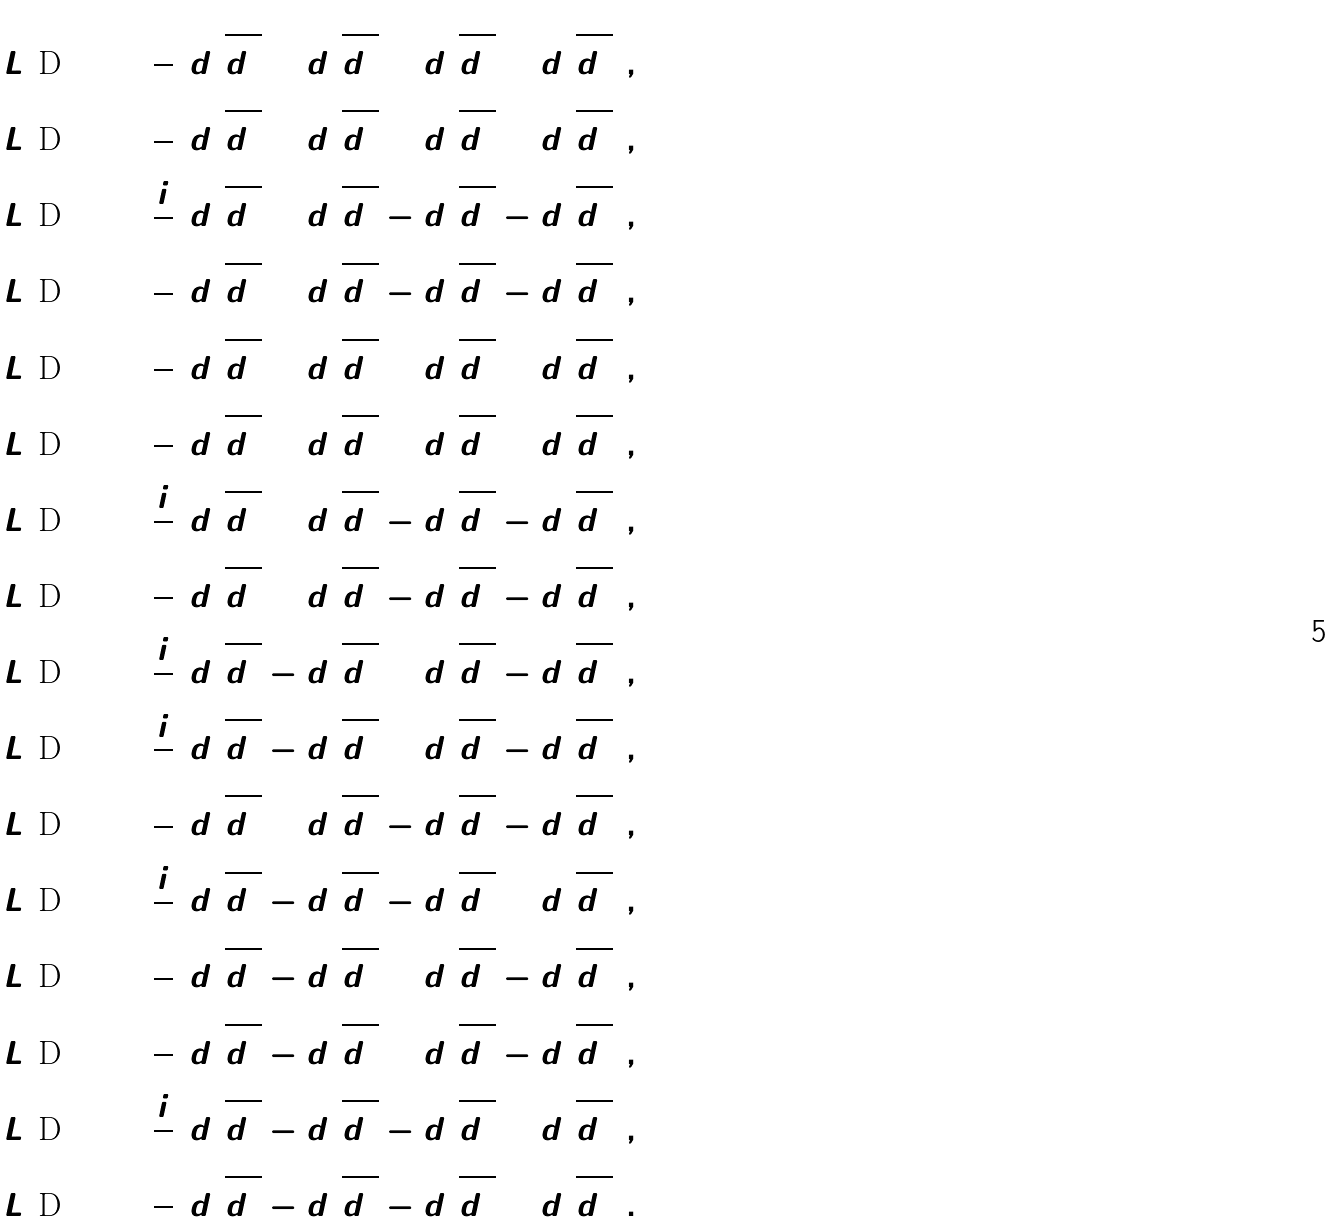Convert formula to latex. <formula><loc_0><loc_0><loc_500><loc_500>L ( \text {D} _ { 2 } ) ^ { 0 } _ { 0 } & = \frac { 1 } { 2 } ( d ^ { 1 } _ { 1 } \overline { d ^ { \dot { 1 } } _ { \dot { 1 } } } + d ^ { 1 } _ { 2 } \overline { d ^ { \dot { 1 } } _ { \dot { 2 } } } + d ^ { 2 } _ { 1 } \overline { d ^ { \dot { 2 } } _ { \dot { 1 } } } + d ^ { 2 } _ { 2 } \overline { d ^ { \dot { 2 } } _ { \dot { 2 } } } ) , \\ L ( \text {D} _ { 2 } ) ^ { 0 } _ { 1 } & = \frac { 1 } { 2 } ( d ^ { 1 } _ { 1 } \overline { d ^ { \dot { 1 } } _ { \dot { 2 } } } + d ^ { 2 } _ { 1 } \overline { d ^ { \dot { 2 } } _ { \dot { 2 } } } + d ^ { 1 } _ { 2 } \overline { d ^ { \dot { 1 } } _ { \dot { 1 } } } + d ^ { 2 } _ { 2 } \overline { d ^ { \dot { 2 } } _ { \dot { 1 } } } ) , \\ L ( \text {D} _ { 2 } ) ^ { 0 } _ { 2 } & = \frac { i } { 2 } ( d ^ { 1 } _ { 2 } \overline { d ^ { \dot { 1 } } _ { \dot { 1 } } } + d ^ { 2 } _ { 2 } \overline { d ^ { \dot { 2 } } _ { \dot { 1 } } } - d ^ { 1 } _ { 1 } \overline { d ^ { \dot { 1 } } _ { \dot { 2 } } } - d ^ { 2 } _ { 1 } \overline { d ^ { \dot { 2 } } _ { \dot { 2 } } } ) , \\ L ( \text {D} _ { 2 } ) ^ { 0 } _ { 3 } & = \frac { 1 } { 2 } ( d ^ { 1 } _ { 1 } \overline { d ^ { \dot { 1 } } _ { \dot { 1 } } } + d ^ { 2 } _ { 1 } \overline { d ^ { \dot { 2 } } _ { \dot { 1 } } } - d ^ { 1 } _ { 2 } \overline { d ^ { \dot { 1 } } _ { \dot { 2 } } } - d ^ { 2 } _ { 2 } \overline { d ^ { \dot { 2 } } _ { \dot { 2 } } } ) , \\ L ( \text {D} _ { 2 } ) ^ { 1 } _ { 0 } & = \frac { 1 } { 2 } ( d ^ { 1 } _ { 1 } \overline { d ^ { \dot { 2 } } _ { \dot { 1 } } } + d ^ { 2 } _ { 1 } \overline { d ^ { \dot { 1 } } _ { \dot { 1 } } } + d ^ { 1 } _ { 2 } \overline { d ^ { \dot { 2 } } _ { \dot { 2 } } } + d ^ { 2 } _ { 2 } \overline { d ^ { \dot { 1 } } _ { \dot { 2 } } } ) , \\ L ( \text {D} _ { 2 } ) ^ { 1 } _ { 1 } & = \frac { 1 } { 2 } ( d ^ { 1 } _ { 1 } \overline { d ^ { \dot { 2 } } _ { \dot { 2 } } } + d ^ { 2 } _ { 1 } \overline { d ^ { \dot { 1 } } _ { \dot { 2 } } } + d ^ { 1 } _ { 2 } \overline { d ^ { \dot { 2 } } _ { \dot { 1 } } } + d ^ { 2 } _ { 2 } \overline { d ^ { \dot { 1 } } _ { \dot { 1 } } } ) , \\ L ( \text {D} _ { 2 } ) ^ { 1 } _ { 2 } & = \frac { i } { 2 } ( d ^ { 1 } _ { 2 } \overline { d ^ { \dot { 2 } } _ { \dot { 1 } } } + d ^ { 2 } _ { 2 } \overline { d ^ { \dot { 1 } } _ { \dot { 1 } } } - d ^ { 1 } _ { 1 } \overline { d ^ { \dot { 2 } } _ { \dot { 2 } } } - d ^ { 2 } _ { 1 } \overline { d ^ { \dot { 1 } } _ { \dot { 2 } } } ) , \\ L ( \text {D} _ { 2 } ) ^ { 1 } _ { 3 } & = \frac { 1 } { 2 } ( d ^ { 1 } _ { 1 } \overline { d ^ { \dot { 2 } } _ { \dot { 1 } } } + d ^ { 2 } _ { 1 } \overline { d ^ { \dot { 1 } } _ { \dot { 1 } } } - d ^ { 1 } _ { 2 } \overline { d ^ { \dot { 2 } } _ { \dot { 2 } } } - d ^ { 2 } _ { 2 } \overline { d ^ { \dot { 1 } } _ { \dot { 2 } } } ) , \\ L ( \text {D} _ { 2 } ) ^ { 2 } _ { 0 } & = \frac { i } { 2 } ( d ^ { 1 } _ { 1 } \overline { d ^ { \dot { 2 } } _ { \dot { 1 } } } - d ^ { 2 } _ { 1 } \overline { d ^ { \dot { 1 } } _ { \dot { 1 } } } + d ^ { 1 } _ { 2 } \overline { d ^ { \dot { 2 } } _ { \dot { 2 } } } - d ^ { 2 } _ { 2 } \overline { d ^ { \dot { 1 } } _ { \dot { 2 } } } ) , \\ L ( \text {D} _ { 2 } ) ^ { 2 } _ { 1 } & = \frac { i } { 2 } ( d ^ { 1 } _ { 1 } \overline { d ^ { \dot { 2 } } _ { \dot { 2 } } } - d ^ { 2 } _ { 1 } \overline { d ^ { \dot { 1 } } _ { \dot { 2 } } } + d ^ { 1 } _ { 2 } \overline { d ^ { \dot { 2 } } _ { \dot { 1 } } } - d ^ { 2 } _ { 2 } \overline { d ^ { \dot { 1 } } _ { \dot { 1 } } } ) , \\ L ( \text {D} _ { 2 } ) ^ { 2 } _ { 2 } & = \frac { 1 } { 2 } ( d ^ { 1 } _ { 1 } \overline { d ^ { \dot { 2 } } _ { \dot { 2 } } } + d ^ { 2 } _ { 2 } \overline { d ^ { \dot { 1 } } _ { \dot { 1 } } } - d ^ { 1 } _ { 2 } \overline { d ^ { \dot { 2 } } _ { \dot { 1 } } } - d ^ { 2 } _ { 1 } \overline { d ^ { \dot { 1 } } _ { \dot { 2 } } } ) , \\ L ( \text {D} _ { 2 } ) ^ { 2 } _ { 3 } & = \frac { i } { 2 } ( d ^ { 1 } _ { 1 } \overline { d ^ { \dot { 2 } } _ { \dot { 1 } } } - d ^ { 2 } _ { 1 } \overline { d ^ { \dot { 1 } } _ { \dot { 1 } } } - d ^ { 1 } _ { 2 } \overline { d ^ { \dot { 2 } } _ { \dot { 2 } } } + d ^ { 2 } _ { 2 } \overline { d ^ { \dot { 1 } } _ { \dot { 2 } } } ) , \\ L ( \text {D} _ { 2 } ) ^ { 3 } _ { 0 } & = \frac { 1 } { 2 } ( d ^ { 1 } _ { 1 } \overline { d ^ { \dot { 1 } } _ { \dot { 1 } } } - d ^ { 2 } _ { 1 } \overline { d ^ { \dot { 2 } } _ { \dot { 1 } } } + d ^ { 1 } _ { 2 } \overline { d ^ { \dot { 1 } } _ { \dot { 2 } } } - d ^ { 2 } _ { 2 } \overline { d ^ { \dot { 2 } } _ { \dot { 2 } } } ) , \\ L ( \text {D} _ { 2 } ) ^ { 3 } _ { 1 } & = \frac { 1 } { 2 } ( d ^ { 1 } _ { 1 } \overline { d ^ { \dot { 1 } } _ { \dot { 2 } } } - d ^ { 2 } _ { 1 } \overline { d ^ { \dot { 2 } } _ { \dot { 2 } } } + d ^ { 1 } _ { 2 } \overline { d ^ { \dot { 1 } } _ { \dot { 1 } } } - d ^ { 2 } _ { 2 } \overline { d ^ { \dot { 2 } } _ { \dot { 1 } } } ) , \\ L ( \text {D} _ { 2 } ) ^ { 3 } _ { 2 } & = \frac { i } { 2 } ( d ^ { 1 } _ { 2 } \overline { d ^ { \dot { 1 } } _ { \dot { 1 } } } - d ^ { 2 } _ { 2 } \overline { d ^ { \dot { 2 } } _ { \dot { 1 } } } - d ^ { 1 } _ { 1 } \overline { d ^ { \dot { 1 } } _ { \dot { 2 } } } + d ^ { 2 } _ { 1 } \overline { d ^ { \dot { 2 } } _ { \dot { 2 } } } ) , \\ L ( \text {D} _ { 2 } ) ^ { 3 } _ { 3 } & = \frac { 1 } { 2 } ( d ^ { 1 } _ { 1 } \overline { d ^ { \dot { 1 } } _ { \dot { 1 } } } - d ^ { 1 } _ { 2 } \overline { d ^ { \dot { 1 } } _ { \dot { 2 } } } - d ^ { 2 } _ { 1 } \overline { d ^ { \dot { 2 } } _ { \dot { 1 } } } + d ^ { 2 } _ { 2 } \overline { d ^ { \dot { 2 } } _ { \dot { 2 } } } ) .</formula> 